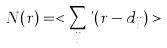<formula> <loc_0><loc_0><loc_500><loc_500>N ( r ) = < \sum _ { i j } \theta ( r - d _ { i j } ) ></formula> 